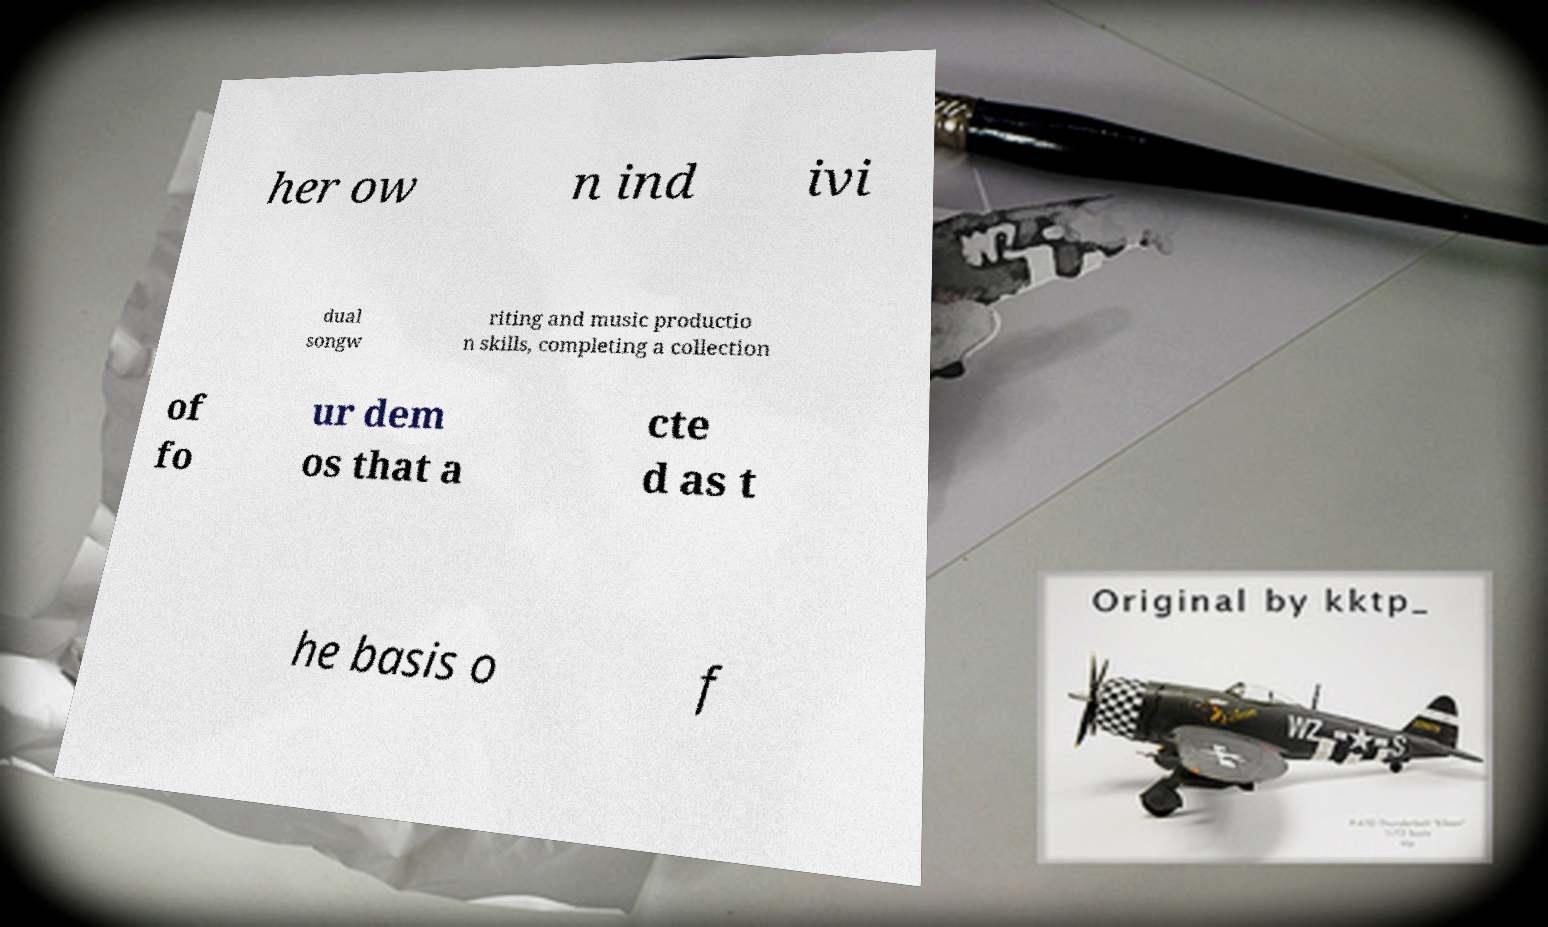Can you accurately transcribe the text from the provided image for me? her ow n ind ivi dual songw riting and music productio n skills, completing a collection of fo ur dem os that a cte d as t he basis o f 